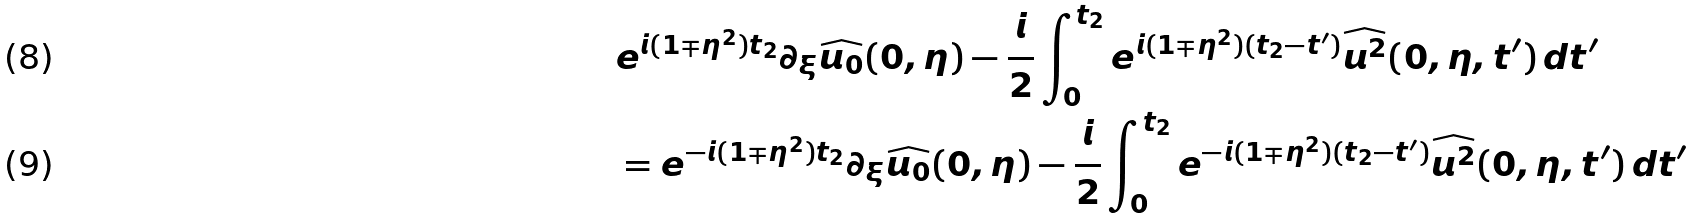<formula> <loc_0><loc_0><loc_500><loc_500>& e ^ { i ( 1 \mp \eta ^ { 2 } ) t _ { 2 } } \partial _ { \xi } \widehat { u _ { 0 } } ( 0 , \eta ) - \frac { i } { 2 } \int _ { 0 } ^ { t _ { 2 } } e ^ { i ( 1 \mp \eta ^ { 2 } ) ( t _ { 2 } - t ^ { \prime } ) } \widehat { u ^ { 2 } } ( 0 , \eta , t ^ { \prime } ) \, d t ^ { \prime } \\ & = e ^ { - i ( 1 \mp \eta ^ { 2 } ) t _ { 2 } } \partial _ { \xi } \widehat { u _ { 0 } } ( 0 , \eta ) - \frac { i } { 2 } \int _ { 0 } ^ { t _ { 2 } } e ^ { - i ( 1 \mp \eta ^ { 2 } ) ( t _ { 2 } - t ^ { \prime } ) } \widehat { u ^ { 2 } } ( 0 , \eta , t ^ { \prime } ) \, d t ^ { \prime }</formula> 